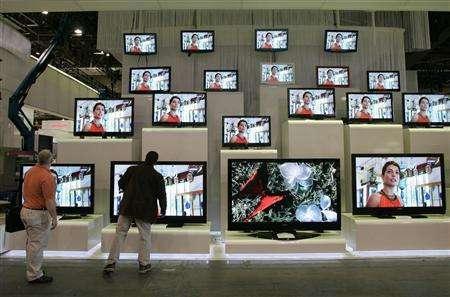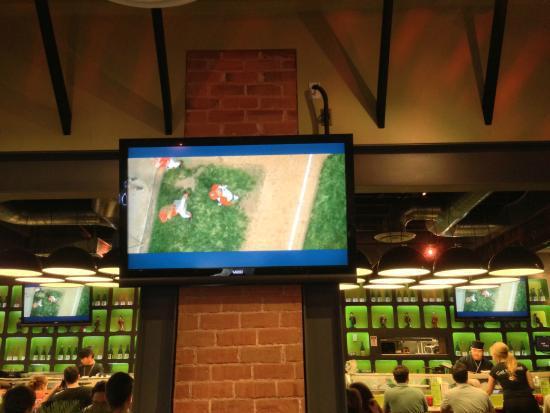The first image is the image on the left, the second image is the image on the right. Given the left and right images, does the statement "An image shows at least four stacked rows that include non-flatscreen type TVs." hold true? Answer yes or no. No. The first image is the image on the left, the second image is the image on the right. For the images displayed, is the sentence "One of the images shows a group of at least ten vintage television sets." factually correct? Answer yes or no. No. 